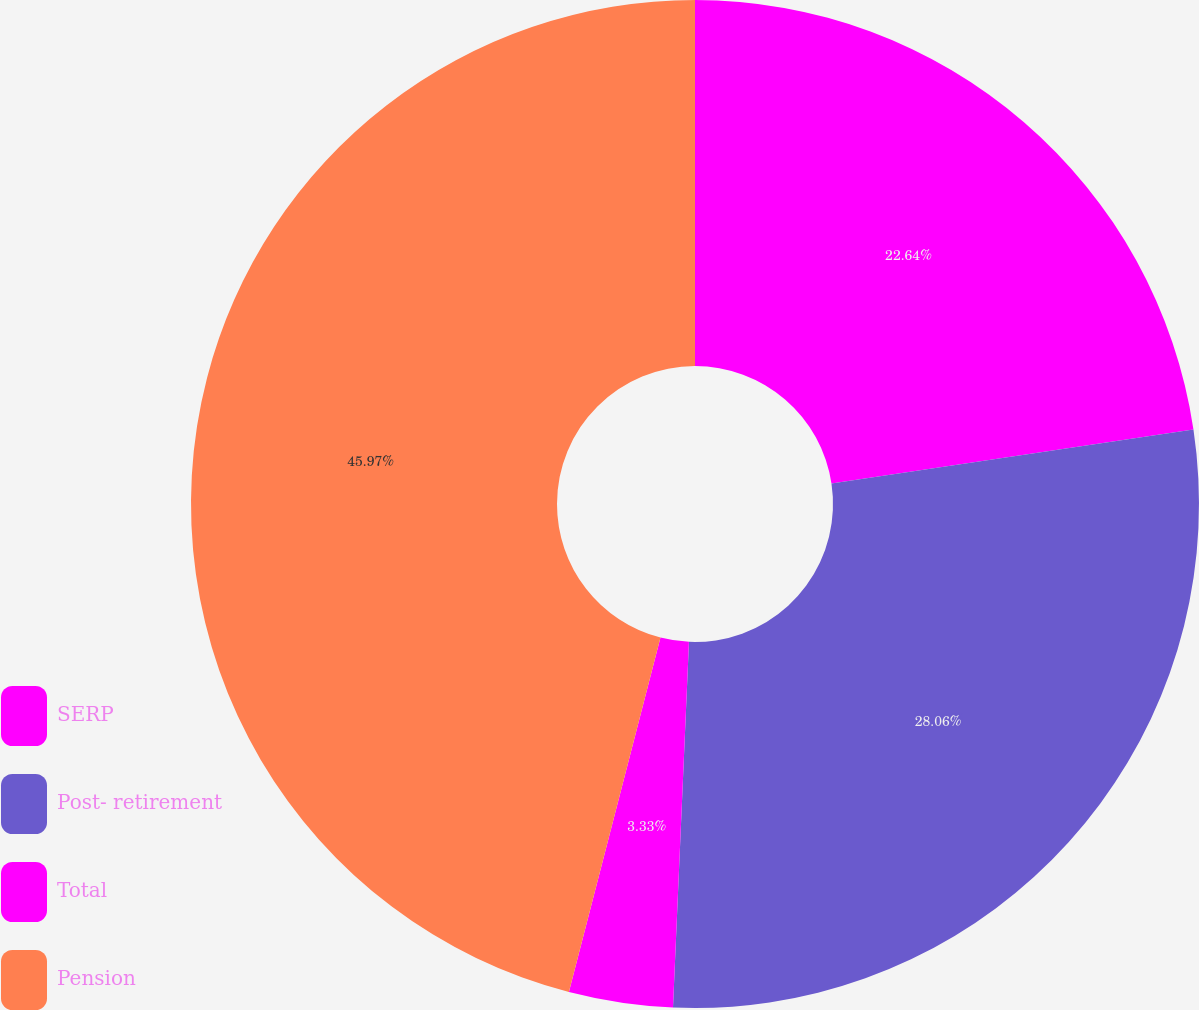Convert chart to OTSL. <chart><loc_0><loc_0><loc_500><loc_500><pie_chart><fcel>SERP<fcel>Post- retirement<fcel>Total<fcel>Pension<nl><fcel>22.64%<fcel>28.06%<fcel>3.33%<fcel>45.98%<nl></chart> 